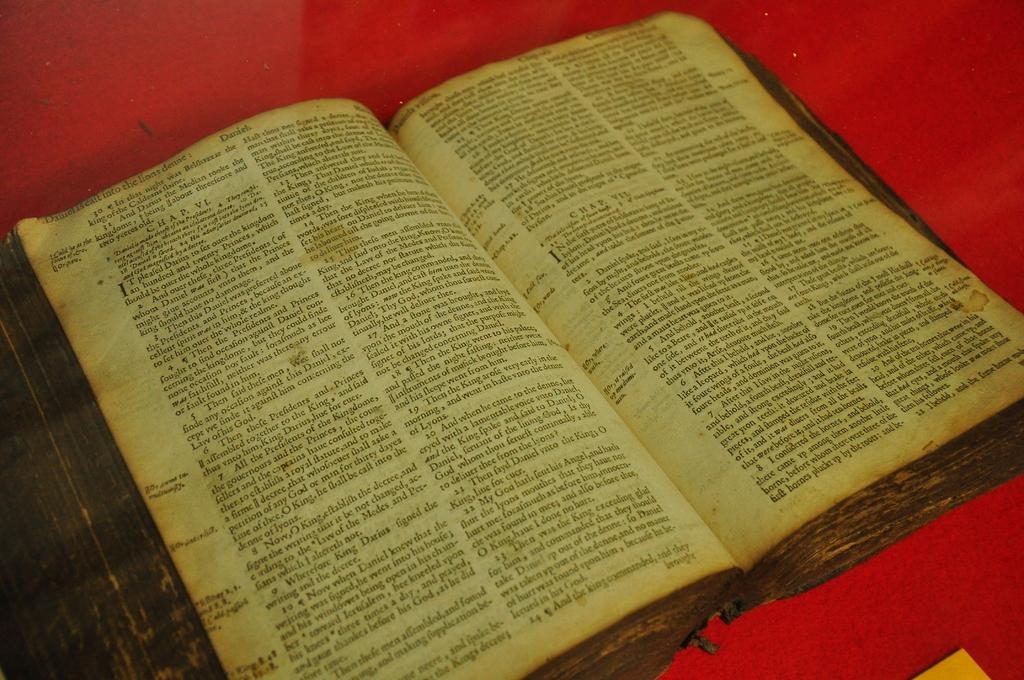<image>
Give a short and clear explanation of the subsequent image. An open bible with faded edges is open to the book of Daniel. 